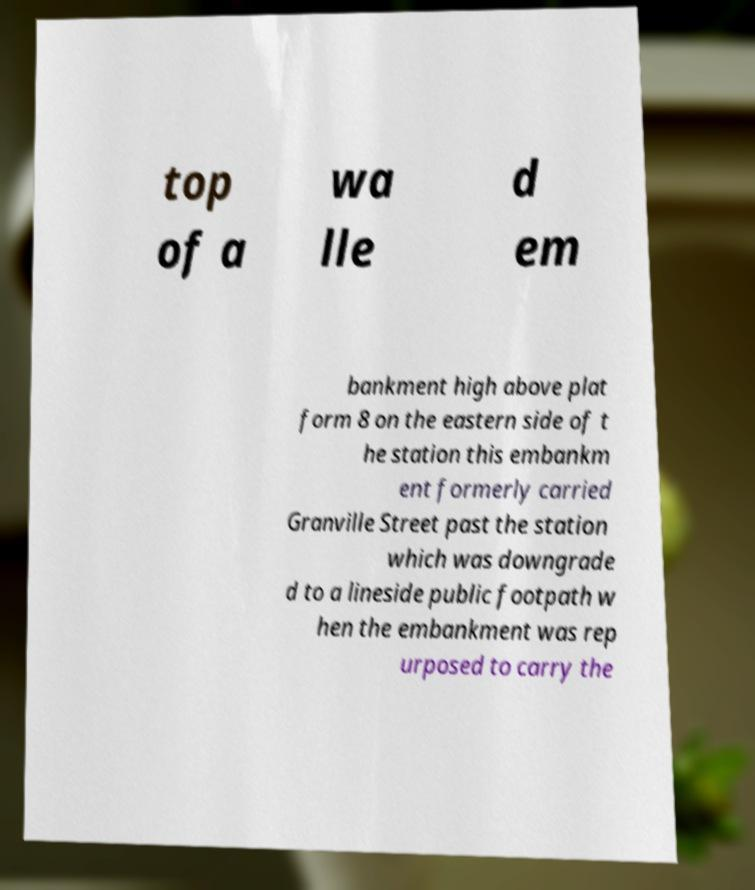Please read and relay the text visible in this image. What does it say? top of a wa lle d em bankment high above plat form 8 on the eastern side of t he station this embankm ent formerly carried Granville Street past the station which was downgrade d to a lineside public footpath w hen the embankment was rep urposed to carry the 